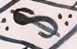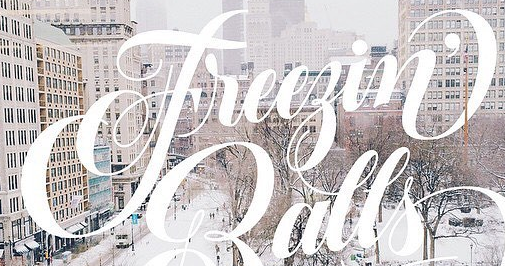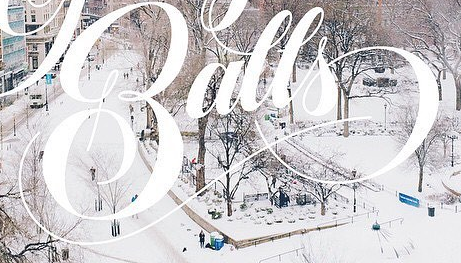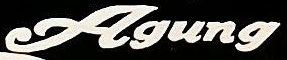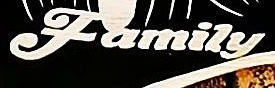What text is displayed in these images sequentially, separated by a semicolon? $; Freegin'; Balls; Agung; Family 